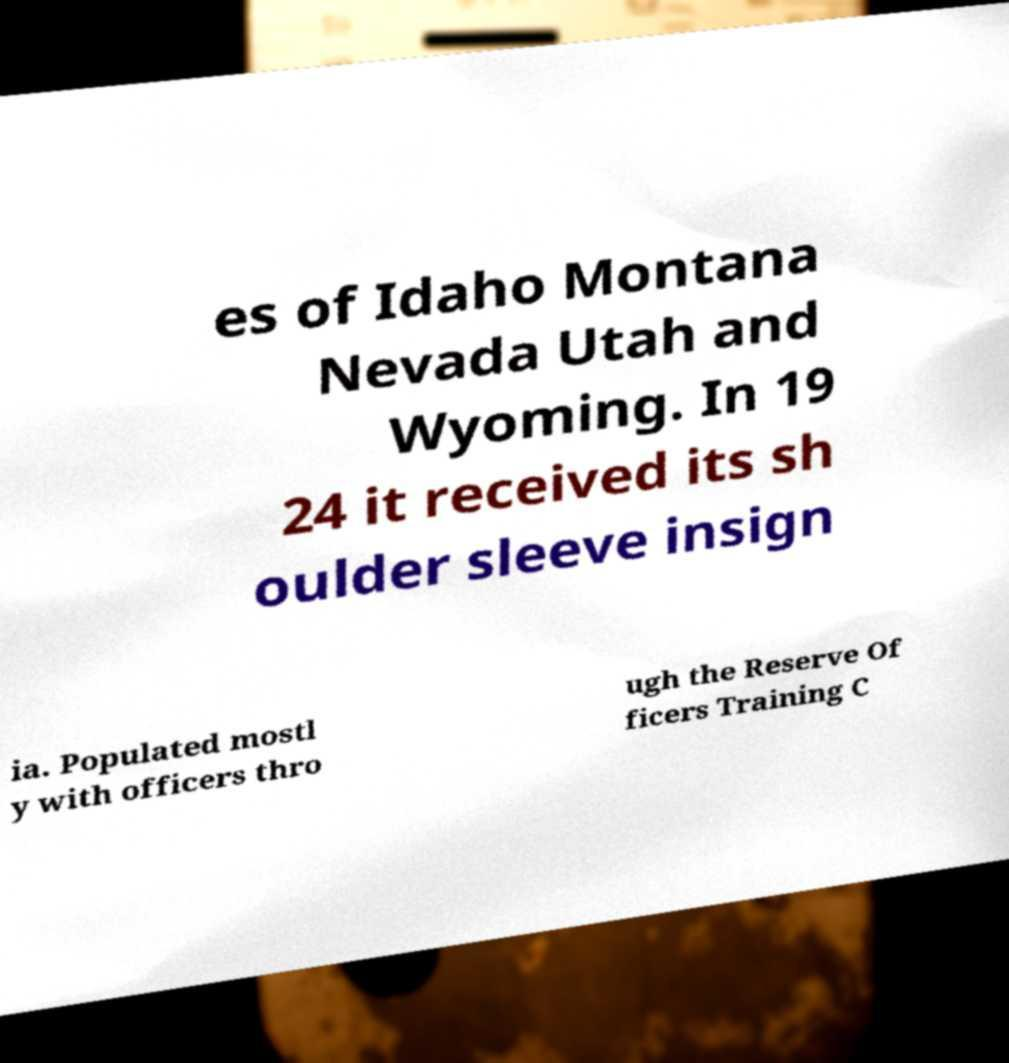I need the written content from this picture converted into text. Can you do that? es of Idaho Montana Nevada Utah and Wyoming. In 19 24 it received its sh oulder sleeve insign ia. Populated mostl y with officers thro ugh the Reserve Of ficers Training C 